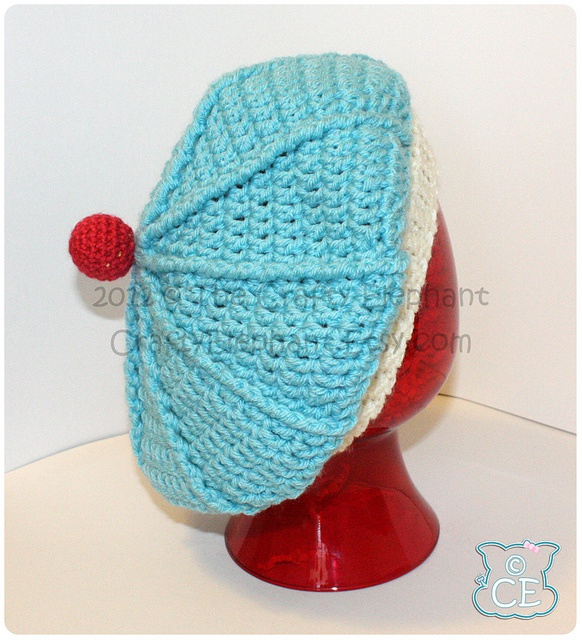Describe the objects in this image and their specific colors. I can see various objects in this image with different colors. 